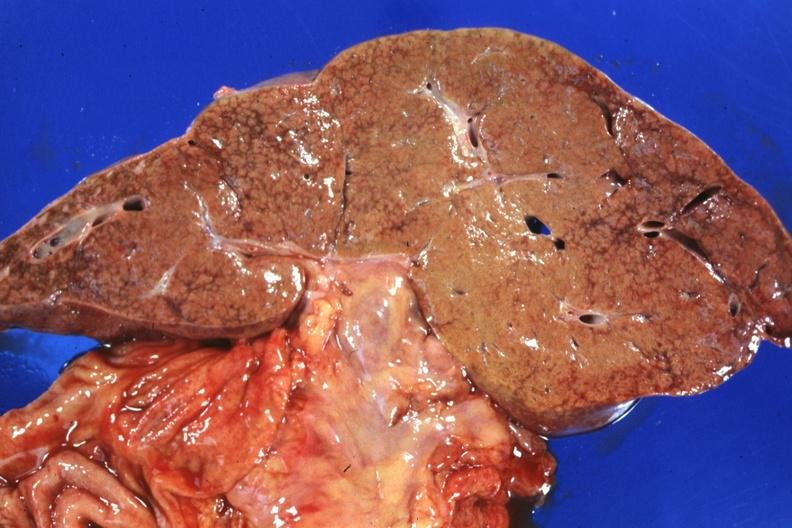what is present?
Answer the question using a single word or phrase. Hepatobiliary 